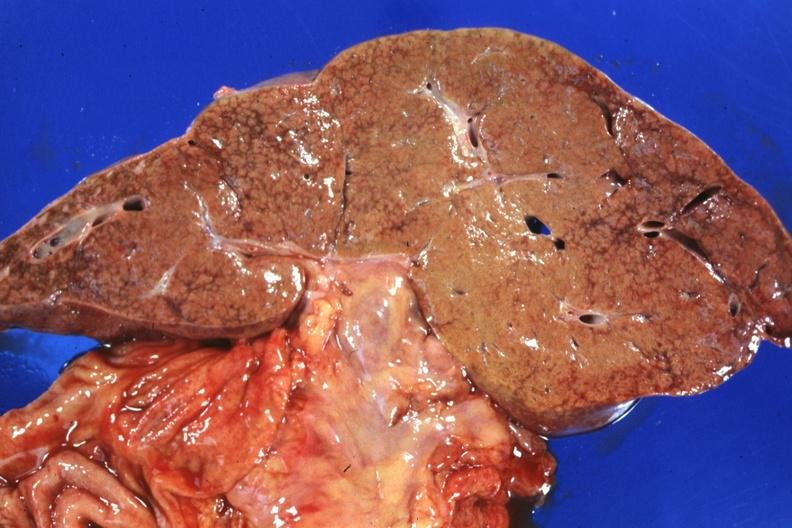what is present?
Answer the question using a single word or phrase. Hepatobiliary 